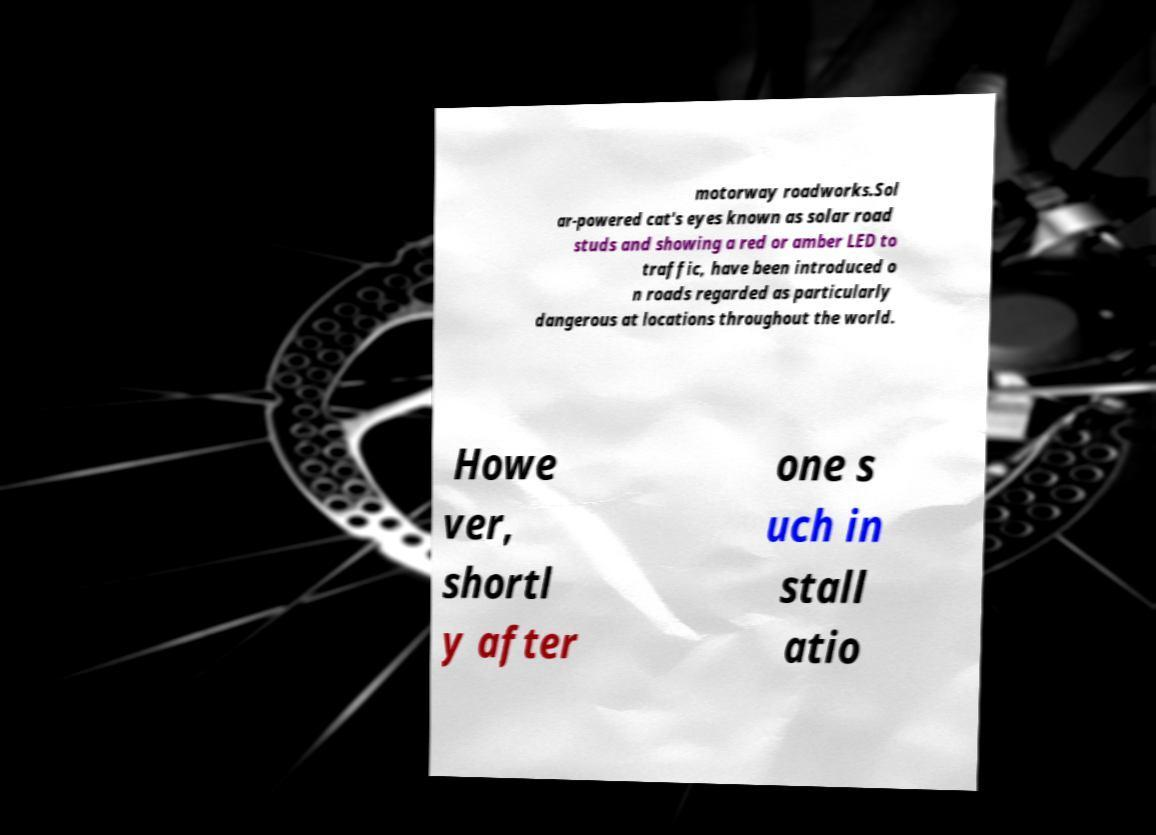Could you assist in decoding the text presented in this image and type it out clearly? motorway roadworks.Sol ar-powered cat's eyes known as solar road studs and showing a red or amber LED to traffic, have been introduced o n roads regarded as particularly dangerous at locations throughout the world. Howe ver, shortl y after one s uch in stall atio 